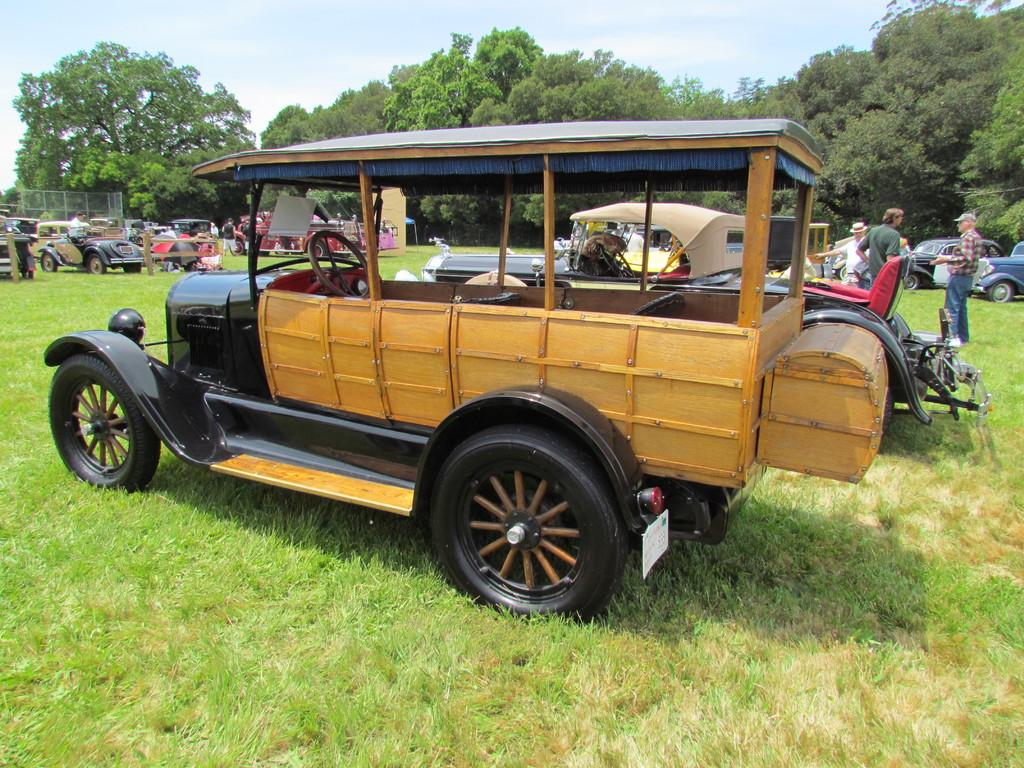What is the primary surface visible in the image? There is a ground in the image. What types of objects can be seen on the ground? Vehicles and persons are present on the ground. What type of barrier is visible in the image? There is a fence in the image. What type of vegetation is visible in the image? Trees are visible in the image. What is visible at the top of the image? The sky is visible at the top of the image. What type of plant life is present on the ground? Grass is visible on the ground. What type of expert can be seen examining a vein in the image? There is no expert or vein present in the image; it features a ground with vehicles, persons, a fence, trees, the sky, and grass. 